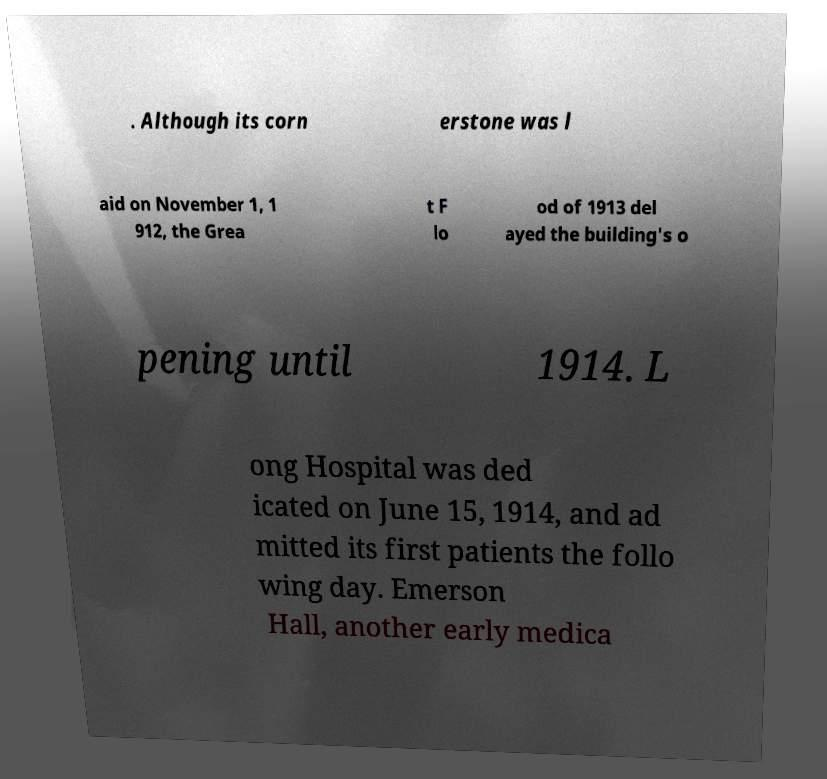For documentation purposes, I need the text within this image transcribed. Could you provide that? . Although its corn erstone was l aid on November 1, 1 912, the Grea t F lo od of 1913 del ayed the building's o pening until 1914. L ong Hospital was ded icated on June 15, 1914, and ad mitted its first patients the follo wing day. Emerson Hall, another early medica 